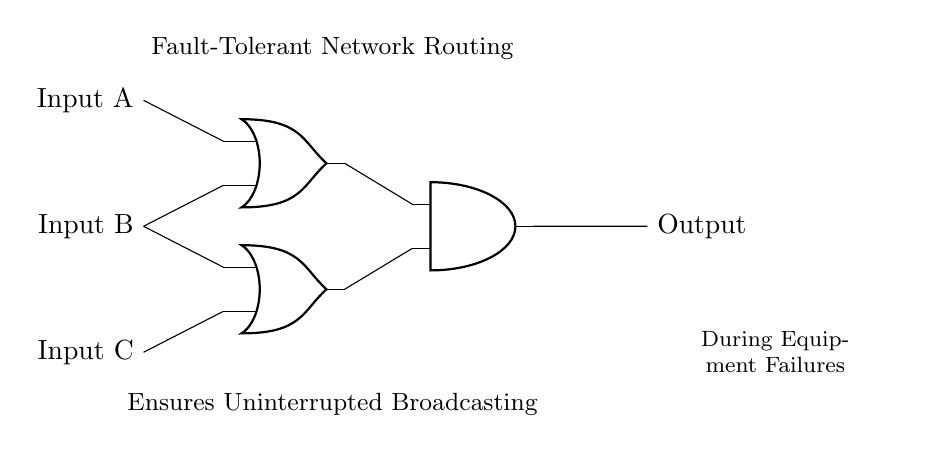What type of gates are used in this circuit? The circuit uses OR gates and an AND gate, which can be identified by their distinct symbols. The presence of these symbols confirms the type of gates.
Answer: OR and AND How many inputs does the circuit have? There are three inputs indicated as Input A, Input B, and Input C connected to the gates at the left side of the circuit.
Answer: Three What is the output of the circuit when all inputs are high? With all inputs high, the OR gates output high signals to the AND gate, which also outputs high given both inputs are high. This indicates that the output will be high.
Answer: High Which gates provide the output to the AND gate? The output from the two OR gates feeds into the AND gate, which means both OR gates are required for the final output.
Answer: Two OR gates What function does the AND gate serve in this circuit? The AND gate combines the outputs of both OR gates, ensuring that only when both conditions from the OR gates are satisfied, the final output will be high.
Answer: Combining outputs In what scenario will the output remain correct despite equipment failures? The circuit is designed for fault tolerance, meaning if one input fails, the remaining inputs can still maintain the operation, ensuring the output remains stable.
Answer: Equipment failures 